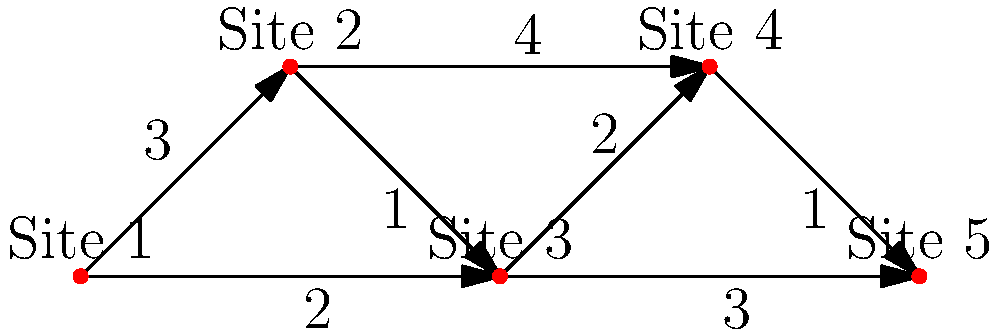In the network diagram above, archaeological sites are represented as nodes, and trade routes are represented as edges with weights indicating the difficulty of travel. What is the minimum total difficulty for a trade route connecting all five sites? To find the minimum total difficulty for a trade route connecting all five sites, we need to find the minimum spanning tree of the network. We can use Kruskal's algorithm to solve this problem:

1. Sort all edges by weight in ascending order:
   (Site 2 - Site 3, weight 1)
   (Site 4 - Site 5, weight 1)
   (Site 1 - Site 3, weight 2)
   (Site 3 - Site 4, weight 2)
   (Site 1 - Site 2, weight 3)
   (Site 3 - Site 5, weight 3)
   (Site 2 - Site 4, weight 4)

2. Start with an empty set of edges and add edges in order, skipping those that would create a cycle:
   a. Add (Site 2 - Site 3, weight 1)
   b. Add (Site 4 - Site 5, weight 1)
   c. Add (Site 1 - Site 3, weight 2)
   d. Add (Site 3 - Site 4, weight 2)

3. At this point, we have connected all five sites without creating any cycles.

4. Calculate the total weight of the minimum spanning tree:
   $1 + 1 + 2 + 2 = 6$

Therefore, the minimum total difficulty for a trade route connecting all five sites is 6.
Answer: 6 